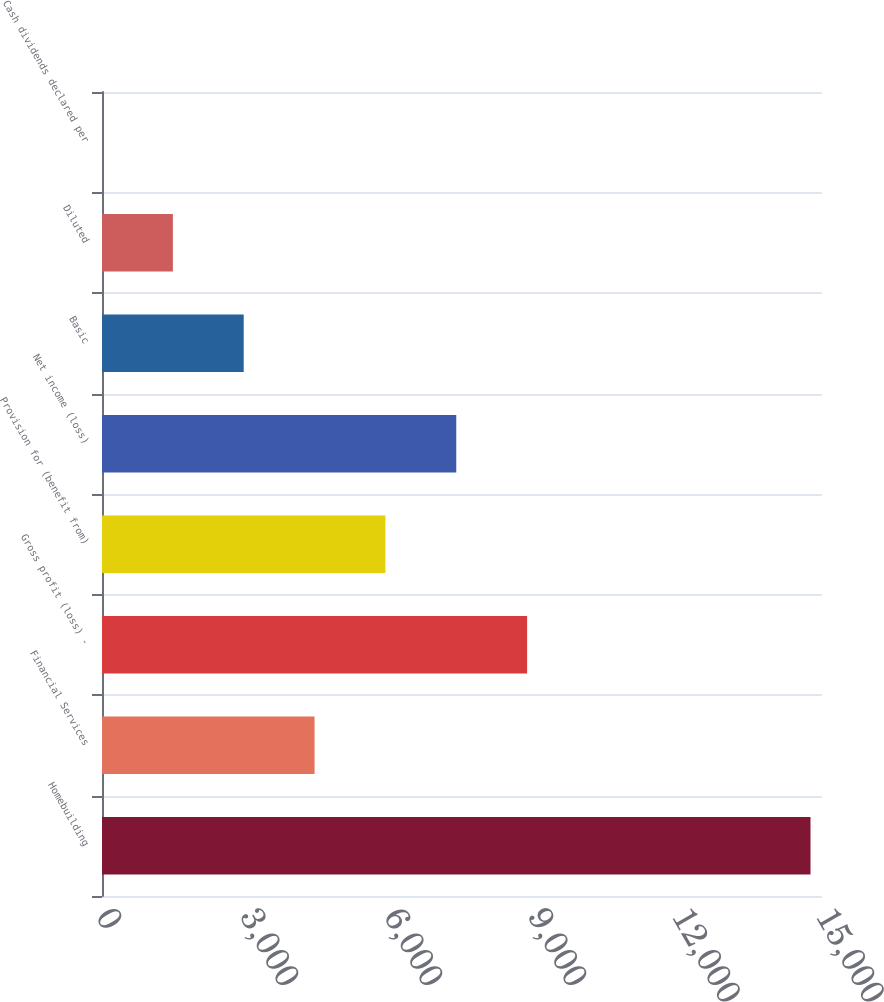Convert chart. <chart><loc_0><loc_0><loc_500><loc_500><bar_chart><fcel>Homebuilding<fcel>Financial Services<fcel>Gross profit (loss) -<fcel>Provision for (benefit from)<fcel>Net income (loss)<fcel>Basic<fcel>Diluted<fcel>Cash dividends declared per<nl><fcel>14760.5<fcel>4428.47<fcel>8856.5<fcel>5904.48<fcel>7380.49<fcel>2952.46<fcel>1476.45<fcel>0.44<nl></chart> 